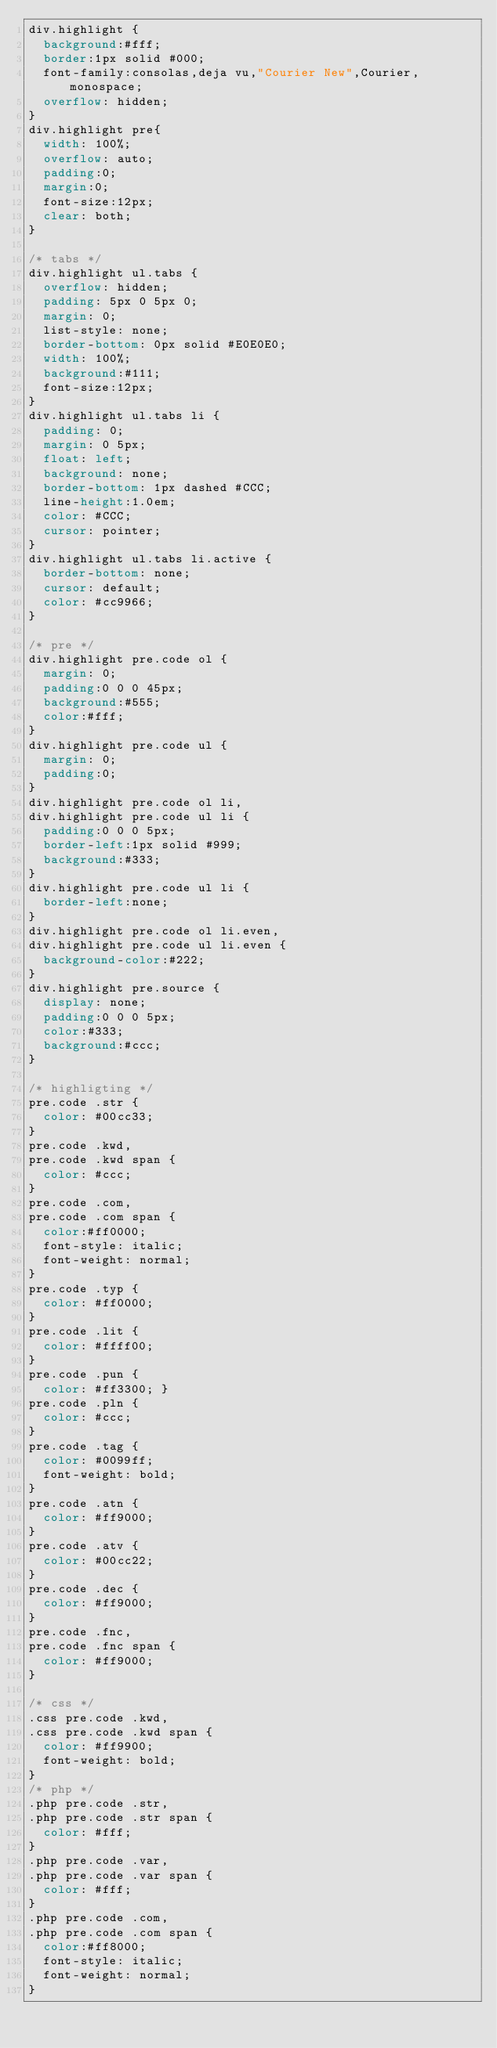<code> <loc_0><loc_0><loc_500><loc_500><_CSS_>div.highlight { 
	background:#fff;
	border:1px solid #000;
	font-family:consolas,deja vu,"Courier New",Courier,monospace;
	overflow: hidden;
}
div.highlight pre{
	width: 100%;
	overflow: auto;
	padding:0;
	margin:0;
	font-size:12px;
	clear: both;
}

/* tabs */
div.highlight ul.tabs {
	overflow: hidden;
	padding: 5px 0 5px 0;
	margin: 0;
	list-style: none;
	border-bottom: 0px solid #E0E0E0;
	width: 100%;
	background:#111;
	font-size:12px;
}
div.highlight ul.tabs li {
	padding: 0;
	margin: 0 5px;
	float: left;
	background: none;
	border-bottom: 1px dashed #CCC;
	line-height:1.0em;
	color: #CCC;
	cursor: pointer;
}
div.highlight ul.tabs li.active {
	border-bottom: none;
	cursor: default;
	color: #cc9966;
}

/* pre */
div.highlight pre.code ol {
	margin: 0;
	padding:0 0 0 45px;
	background:#555; 
	color:#fff; 
}
div.highlight pre.code ul {
	margin: 0;
	padding:0;	
}
div.highlight pre.code ol li,
div.highlight pre.code ul li {
	padding:0 0 0 5px;
	border-left:1px solid #999;
	background:#333;
}
div.highlight pre.code ul li {
	border-left:none;
}
div.highlight pre.code ol li.even,
div.highlight pre.code ul li.even {
	background-color:#222;
}
div.highlight pre.source {
	display: none;
	padding:0 0 0 5px;
	color:#333;
	background:#ccc;
}

/* highligting */
pre.code .str { 
	color: #00cc33; 
}
pre.code .kwd,
pre.code .kwd span { 
	color: #ccc;
}
pre.code .com,
pre.code .com span { 
	color:#ff0000;
	font-style: italic;
	font-weight: normal; 
}
pre.code .typ { 
	color: #ff0000; 
}
pre.code .lit { 
	color: #ffff00;
}
pre.code .pun { 
	color: #ff3300; }
pre.code .pln { 
	color: #ccc; 
}
pre.code .tag { 
	color: #0099ff;
	font-weight: bold;  
} 
pre.code .atn { 
	color: #ff9000; 
}
pre.code .atv { 
	color: #00cc22; 
}
pre.code .dec { 
	color: #ff9000; 
}
pre.code .fnc,
pre.code .fnc span { 
	color: #ff9000; 
}

/* css */
.css pre.code .kwd,
.css pre.code .kwd span { 
	color: #ff9900;
	font-weight: bold; 
}
/* php */
.php pre.code .str,
.php pre.code .str span { 
	color: #fff; 
}
.php pre.code .var,
.php pre.code .var span { 
	color: #fff; 
}
.php pre.code .com,
.php pre.code .com span { 
	color:#ff8000;
	font-style: italic;
	font-weight: normal; 
}</code> 